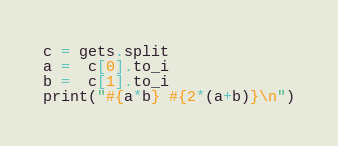<code> <loc_0><loc_0><loc_500><loc_500><_Ruby_>c = gets.split
a =  c[0].to_i
b =  c[1].to_i
print("#{a*b} #{2*(a+b)}\n")</code> 